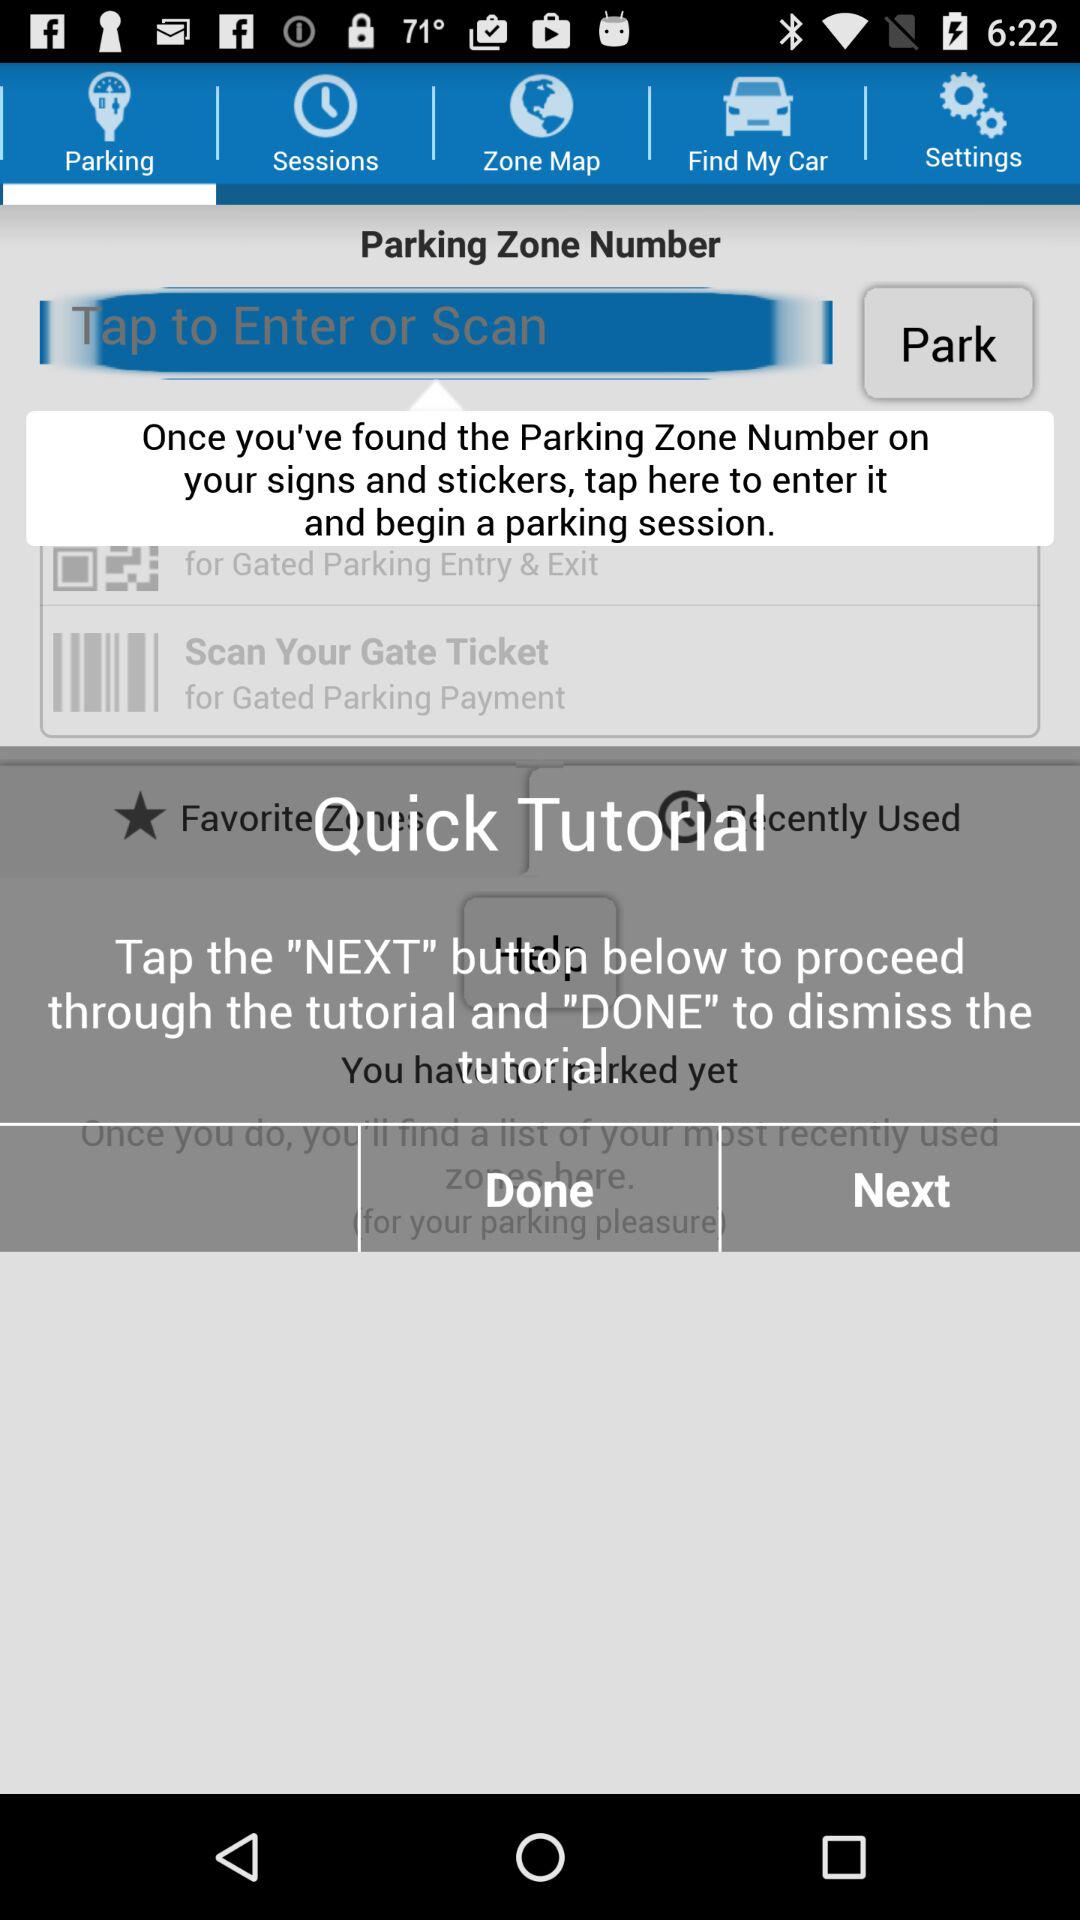What is the selected tab? The selected tab is "Parking". 